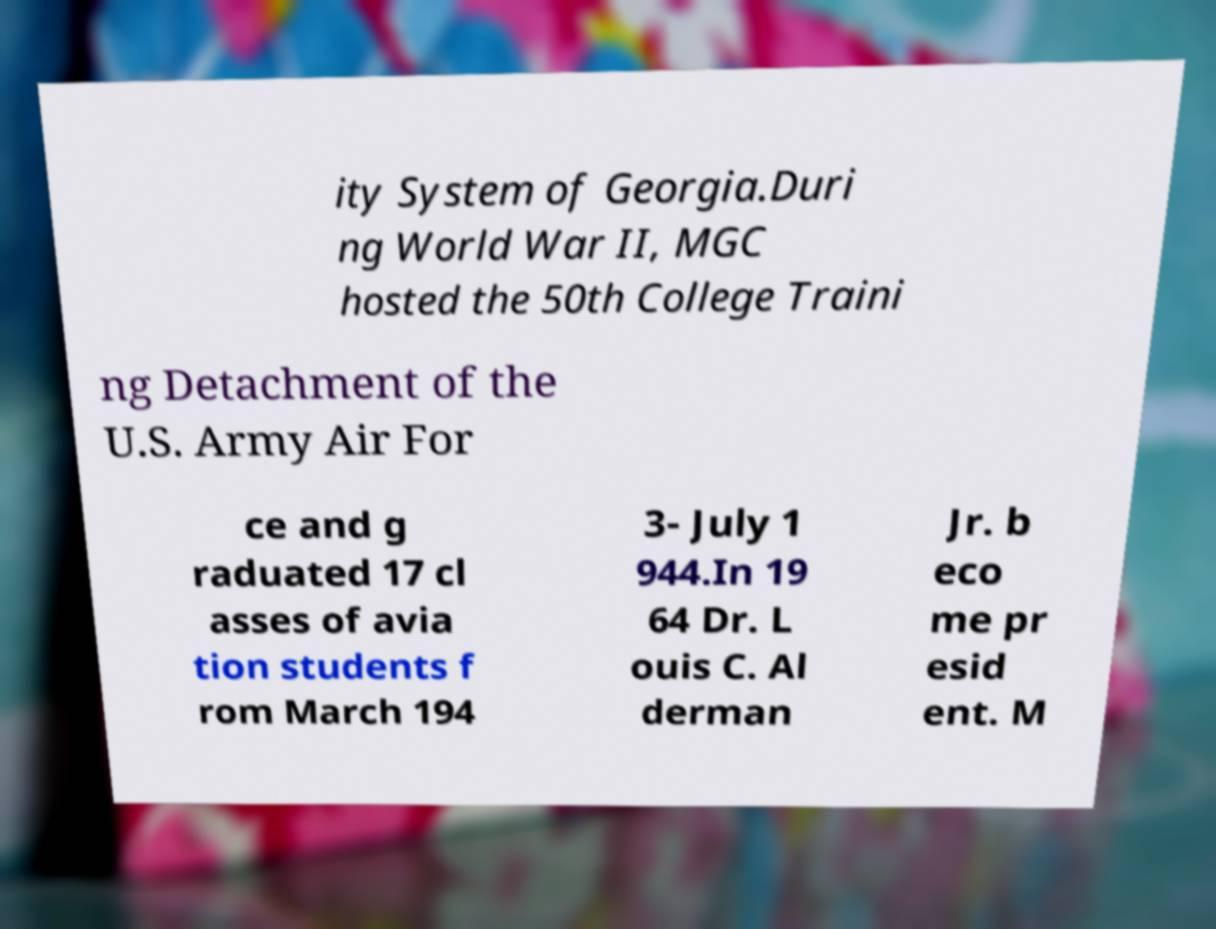There's text embedded in this image that I need extracted. Can you transcribe it verbatim? ity System of Georgia.Duri ng World War II, MGC hosted the 50th College Traini ng Detachment of the U.S. Army Air For ce and g raduated 17 cl asses of avia tion students f rom March 194 3- July 1 944.In 19 64 Dr. L ouis C. Al derman Jr. b eco me pr esid ent. M 